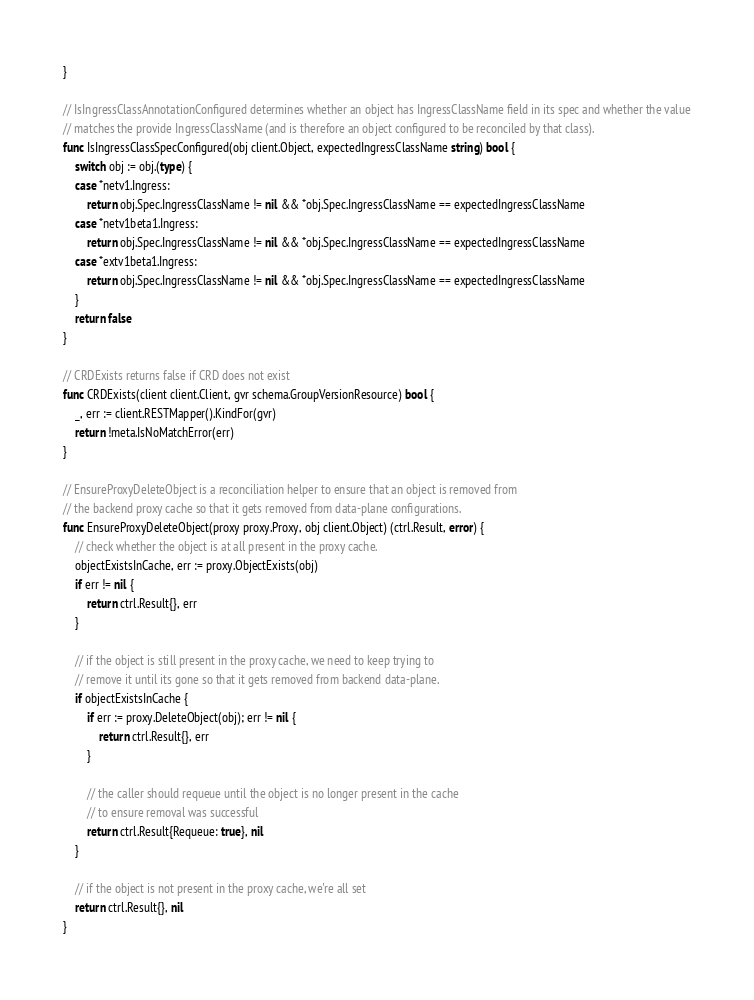Convert code to text. <code><loc_0><loc_0><loc_500><loc_500><_Go_>}

// IsIngressClassAnnotationConfigured determines whether an object has IngressClassName field in its spec and whether the value
// matches the provide IngressClassName (and is therefore an object configured to be reconciled by that class).
func IsIngressClassSpecConfigured(obj client.Object, expectedIngressClassName string) bool {
	switch obj := obj.(type) {
	case *netv1.Ingress:
		return obj.Spec.IngressClassName != nil && *obj.Spec.IngressClassName == expectedIngressClassName
	case *netv1beta1.Ingress:
		return obj.Spec.IngressClassName != nil && *obj.Spec.IngressClassName == expectedIngressClassName
	case *extv1beta1.Ingress:
		return obj.Spec.IngressClassName != nil && *obj.Spec.IngressClassName == expectedIngressClassName
	}
	return false
}

// CRDExists returns false if CRD does not exist
func CRDExists(client client.Client, gvr schema.GroupVersionResource) bool {
	_, err := client.RESTMapper().KindFor(gvr)
	return !meta.IsNoMatchError(err)
}

// EnsureProxyDeleteObject is a reconciliation helper to ensure that an object is removed from
// the backend proxy cache so that it gets removed from data-plane configurations.
func EnsureProxyDeleteObject(proxy proxy.Proxy, obj client.Object) (ctrl.Result, error) {
	// check whether the object is at all present in the proxy cache.
	objectExistsInCache, err := proxy.ObjectExists(obj)
	if err != nil {
		return ctrl.Result{}, err
	}

	// if the object is still present in the proxy cache, we need to keep trying to
	// remove it until its gone so that it gets removed from backend data-plane.
	if objectExistsInCache {
		if err := proxy.DeleteObject(obj); err != nil {
			return ctrl.Result{}, err
		}

		// the caller should requeue until the object is no longer present in the cache
		// to ensure removal was successful
		return ctrl.Result{Requeue: true}, nil
	}

	// if the object is not present in the proxy cache, we're all set
	return ctrl.Result{}, nil
}
</code> 